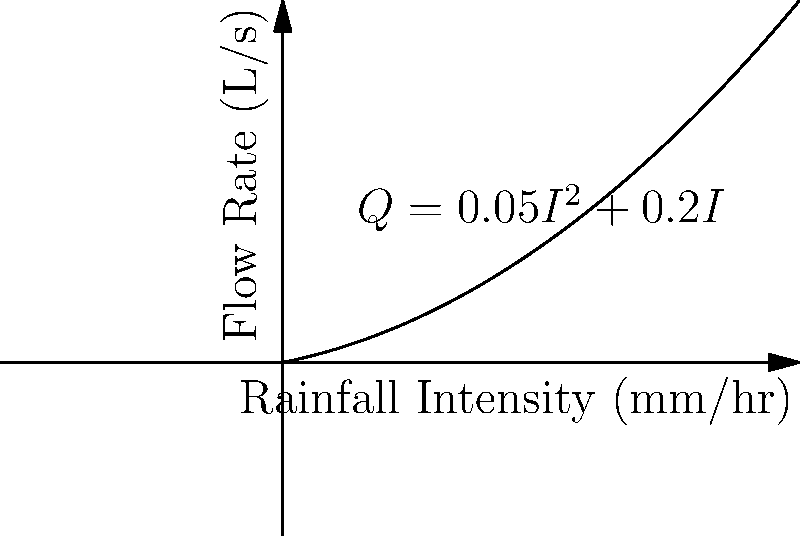A sustainable drainage system for a sports field uses the equation $Q = 0.05I^2 + 0.2I$ to model the flow rate (Q) in L/s based on rainfall intensity (I) in mm/hr. If the design rainfall intensity for a 1-in-100-year storm event is 80 mm/hr, what is the maximum flow rate the system needs to handle? Round your answer to the nearest whole number. To solve this problem, we need to follow these steps:

1. Identify the given information:
   - Equation: $Q = 0.05I^2 + 0.2I$
   - Rainfall intensity (I) = 80 mm/hr

2. Substitute the rainfall intensity into the equation:
   $Q = 0.05(80)^2 + 0.2(80)$

3. Calculate the squared term:
   $Q = 0.05(6400) + 0.2(80)$

4. Multiply:
   $Q = 320 + 16$

5. Add the results:
   $Q = 336$ L/s

6. Round to the nearest whole number:
   $Q ≈ 336$ L/s (no rounding needed in this case)

Therefore, the maximum flow rate the system needs to handle is 336 L/s.
Answer: 336 L/s 